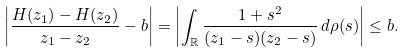Convert formula to latex. <formula><loc_0><loc_0><loc_500><loc_500>\left | \frac { H ( z _ { 1 } ) - H ( z _ { 2 } ) } { z _ { 1 } - z _ { 2 } } - b \right | = \left | \int _ { \mathbb { R } } \frac { 1 + s ^ { 2 } } { ( z _ { 1 } - s ) ( z _ { 2 } - s ) } \, d \rho ( s ) \right | \leq b .</formula> 